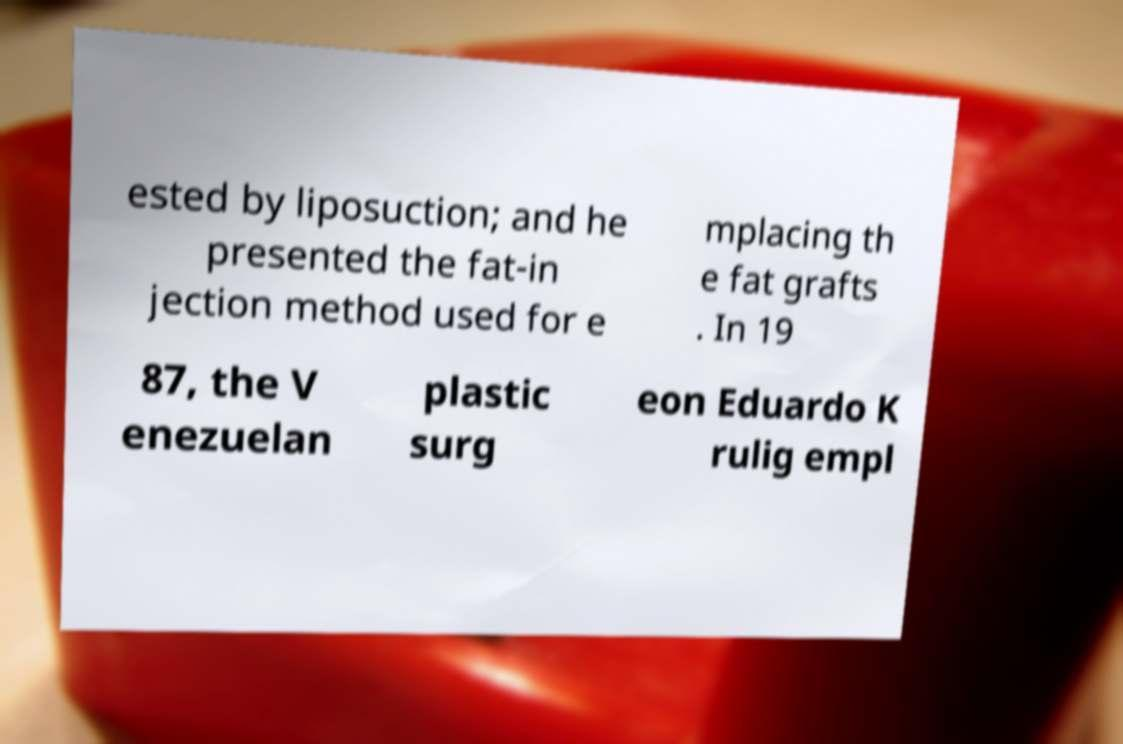Could you extract and type out the text from this image? ested by liposuction; and he presented the fat-in jection method used for e mplacing th e fat grafts . In 19 87, the V enezuelan plastic surg eon Eduardo K rulig empl 